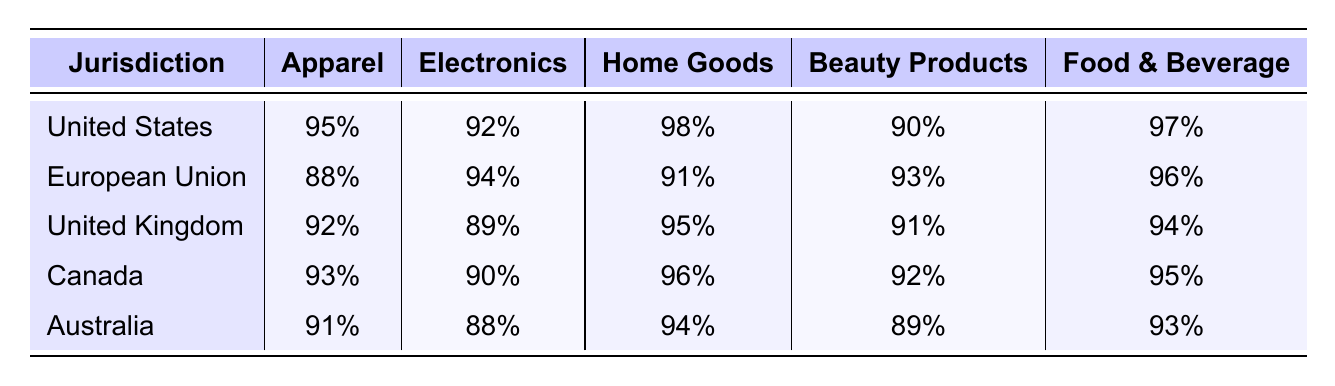What is the compliance percentage for Beauty Products in the United States? The table indicates that in the United States, the compliance percentage for Beauty Products is stated directly as 90%.
Answer: 90% Which jurisdiction has the highest compliance percentage for Home Goods? By reviewing the table, we see that the United States has the highest compliance percentage for Home Goods at 98%.
Answer: United States What is the average compliance percentage for Electronics across all jurisdictions? To find the average for Electronics, we sum the compliance percentages: (92 + 94 + 89 + 90 + 88) = 453. We then divide by the number of jurisdictions, which is 5, giving us an average of 453/5 = 90.6%.
Answer: 90.6% Is the compliance for Food & Beverage in the European Union higher than in Australia? The compliance percentage for Food & Beverage in the European Union is 96%, while in Australia it is 93%. Since 96% is greater than 93%, the statement is true.
Answer: Yes Which product line shows the least compliance in the United Kingdom? By examining the compliance percentages for the United Kingdom, we see that the Electronics line has the lowest percentage at 89%.
Answer: Electronics How does the compliance percentage for Apparel compare between Canada and the United Kingdom? For Canada, the Apparel compliance percentage is 93%, and for the United Kingdom, it is 92%. Since 93% (Canada) is greater than 92% (United Kingdom), Canada has a higher compliance percentage.
Answer: Canada has higher compliance What is the difference in compliance percentages for Home Goods between the United States and the European Union? The United States has a compliance percentage of 98% for Home Goods, while the European Union has 91%. The difference is 98% - 91% = 7%.
Answer: 7% Which jurisdiction has a lower compliance percentage in Electronics: Australia or the United Kingdom? In Australia, the compliance percentage for Electronics is 88%, while in the United Kingdom it is 89%. Since 88% is less than 89%, Australia has a lower percentage.
Answer: Australia Identify the jurisdiction that has the second-lowest compliance percentage for Apparel. The compliance percentages for Apparel are: United States (95%), Canada (93%), United Kingdom (92%), Australia (91%), and European Union (88%). Arranging these from highest to lowest, the second-lowest is the United Kingdom at 92%.
Answer: United Kingdom What product line has the highest compliance percentage across all jurisdictions? The highest individual compliance percentage for a product line is for Home Goods in the United States at 98%. This can be confirmed by reviewing the compliance percentages for all product lines across jurisdictions.
Answer: Home Goods Are there any jurisdictions where compliance for Electronics is below 90%? The table shows that the compliance for Electronics is 88% in Australia and 89% in the United Kingdom, which are both below 90%.
Answer: Yes 